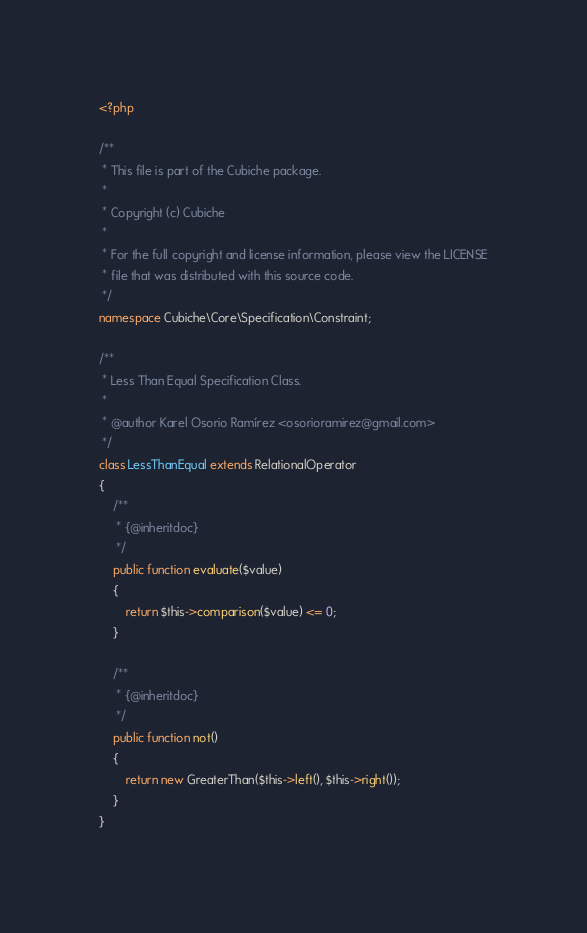Convert code to text. <code><loc_0><loc_0><loc_500><loc_500><_PHP_><?php

/**
 * This file is part of the Cubiche package.
 *
 * Copyright (c) Cubiche
 *
 * For the full copyright and license information, please view the LICENSE
 * file that was distributed with this source code.
 */
namespace Cubiche\Core\Specification\Constraint;

/**
 * Less Than Equal Specification Class.
 *
 * @author Karel Osorio Ramírez <osorioramirez@gmail.com>
 */
class LessThanEqual extends RelationalOperator
{
    /**
     * {@inheritdoc}
     */
    public function evaluate($value)
    {
        return $this->comparison($value) <= 0;
    }

    /**
     * {@inheritdoc}
     */
    public function not()
    {
        return new GreaterThan($this->left(), $this->right());
    }
}
</code> 